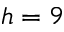Convert formula to latex. <formula><loc_0><loc_0><loc_500><loc_500>h = 9</formula> 